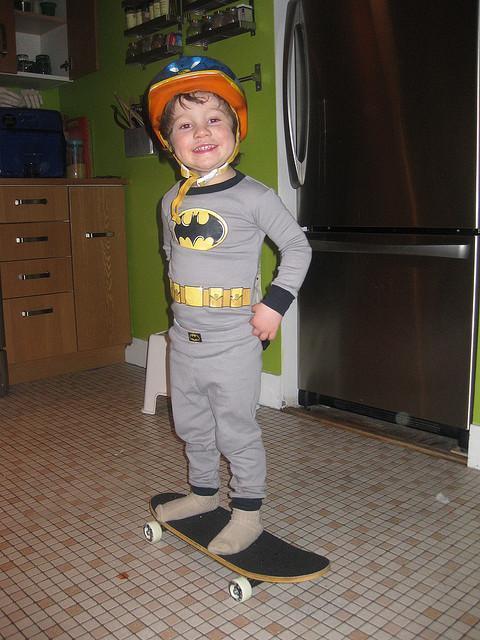How many kids are in the room?
Give a very brief answer. 1. How many refrigerators are there?
Give a very brief answer. 1. 